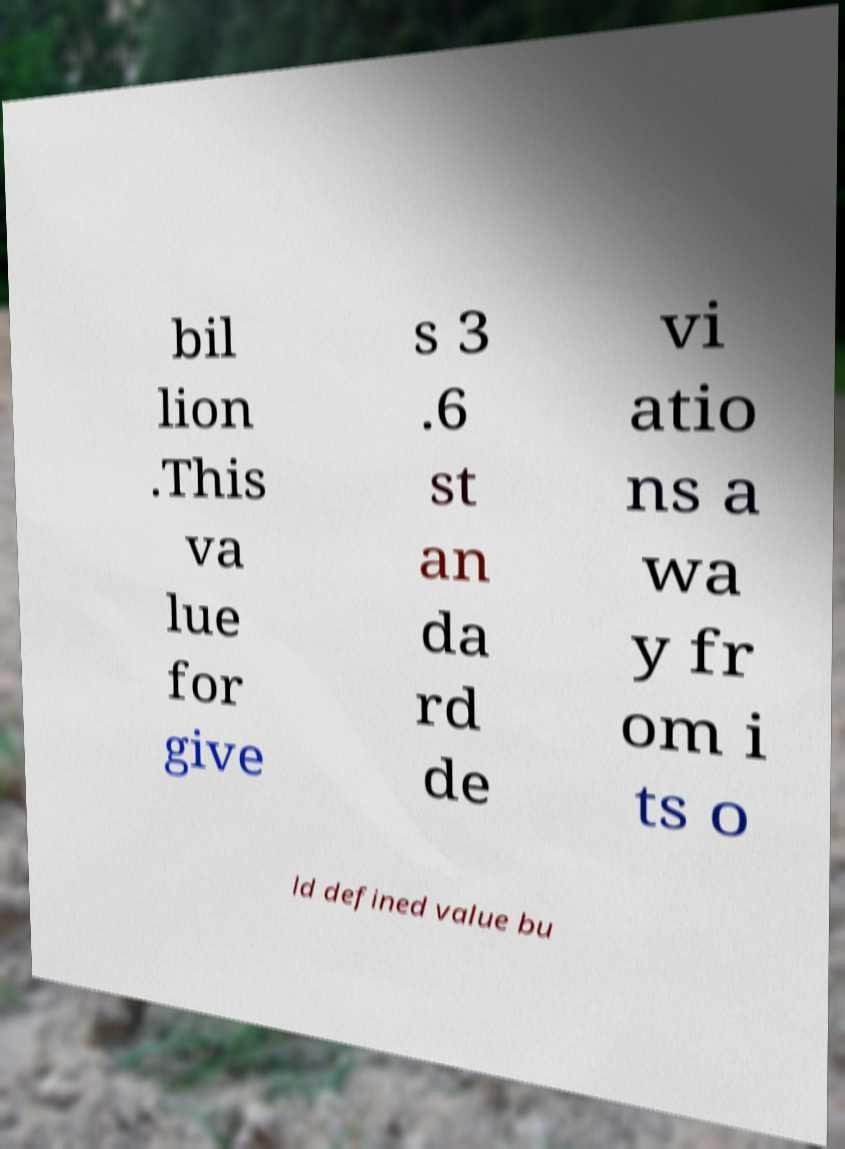Can you accurately transcribe the text from the provided image for me? bil lion .This va lue for give s 3 .6 st an da rd de vi atio ns a wa y fr om i ts o ld defined value bu 